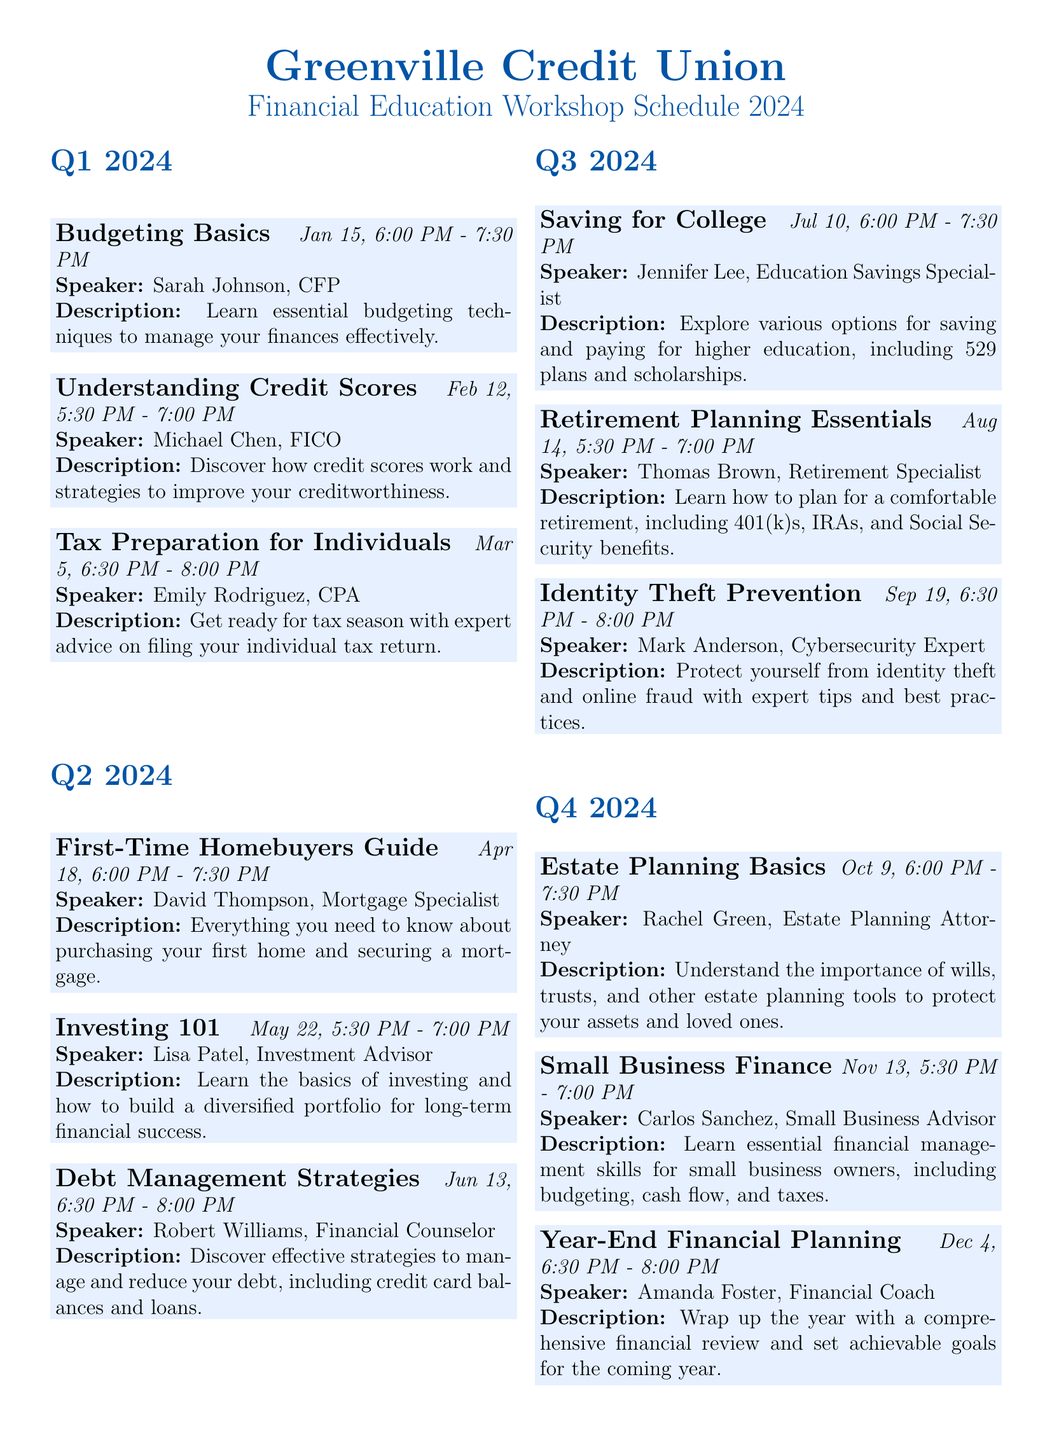What is the date of the first workshop? The first workshop in Q1 2024 is "Budgeting Basics," scheduled for January 15, 2024.
Answer: January 15, 2024 Who is the speaker for the "Understanding Credit Scores" workshop? The workshop "Understanding Credit Scores" features Michael Chen, a Credit Counselor from FICO.
Answer: Michael Chen How long does the "Tax Preparation for Individuals" workshop last? The workshop is scheduled for 1.5 hours, from 6:30 PM to 8:00 PM.
Answer: 1.5 hours What is the topic of the Q2 workshop on May 22, 2024? The topic for the Q2 workshop on May 22, 2024, is "Investing 101: Building Wealth for the Future."
Answer: Investing 101 Which workshop focuses on retirement planning? The "Retirement Planning Essentials" workshop focuses on retirement planning.
Answer: Retirement Planning Essentials How many workshops are there in Q4? The document outlines three workshops scheduled for Q4 2024.
Answer: Three What is the registration method for the workshops? Participants can register online or in-person at any branch.
Answer: Online or in-person Are refreshments provided at the workshops? The document specifies that light refreshments will be provided at all workshops.
Answer: Yes What is the location of the workshops? The workshops are held in the Community Room of the Main Branch of Greenville Credit Union.
Answer: Community Room, Main Branch of Greenville Credit Union 